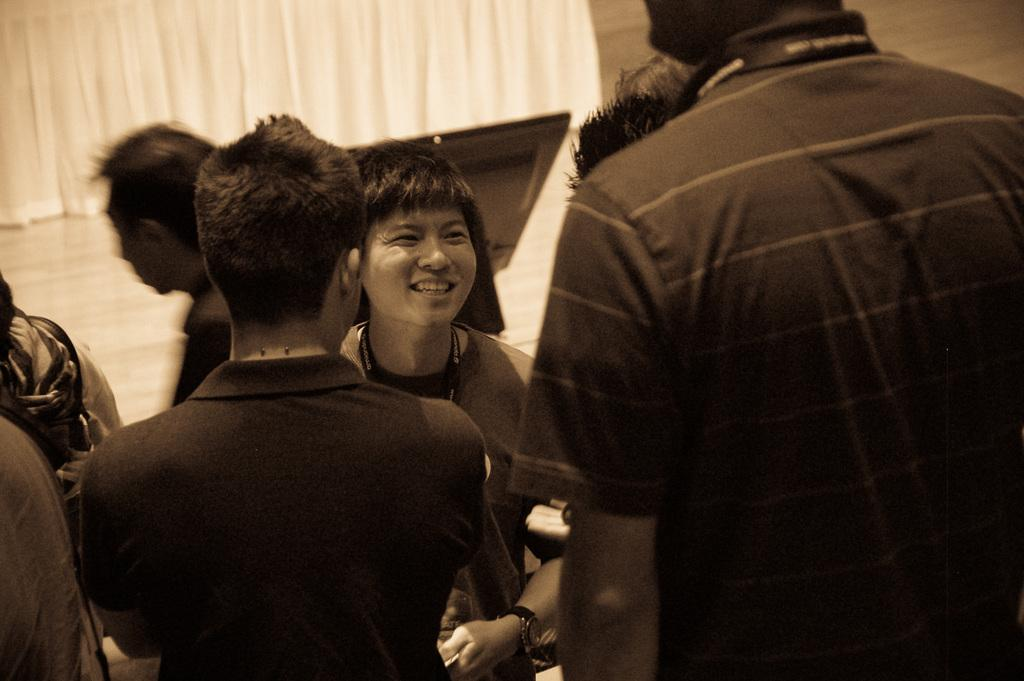How many people are in the image? There is a group of people in the image. What are the people wearing? The people are wearing dresses. What can be seen in the background of the image? There is a floor and a curtain visible in the background of the image. What is the color scheme of the image? The image is black and white. What type of rod can be seen in the hands of the people in the image? There is no rod present in the image; the people are wearing dresses and there is no indication of any object being held. 